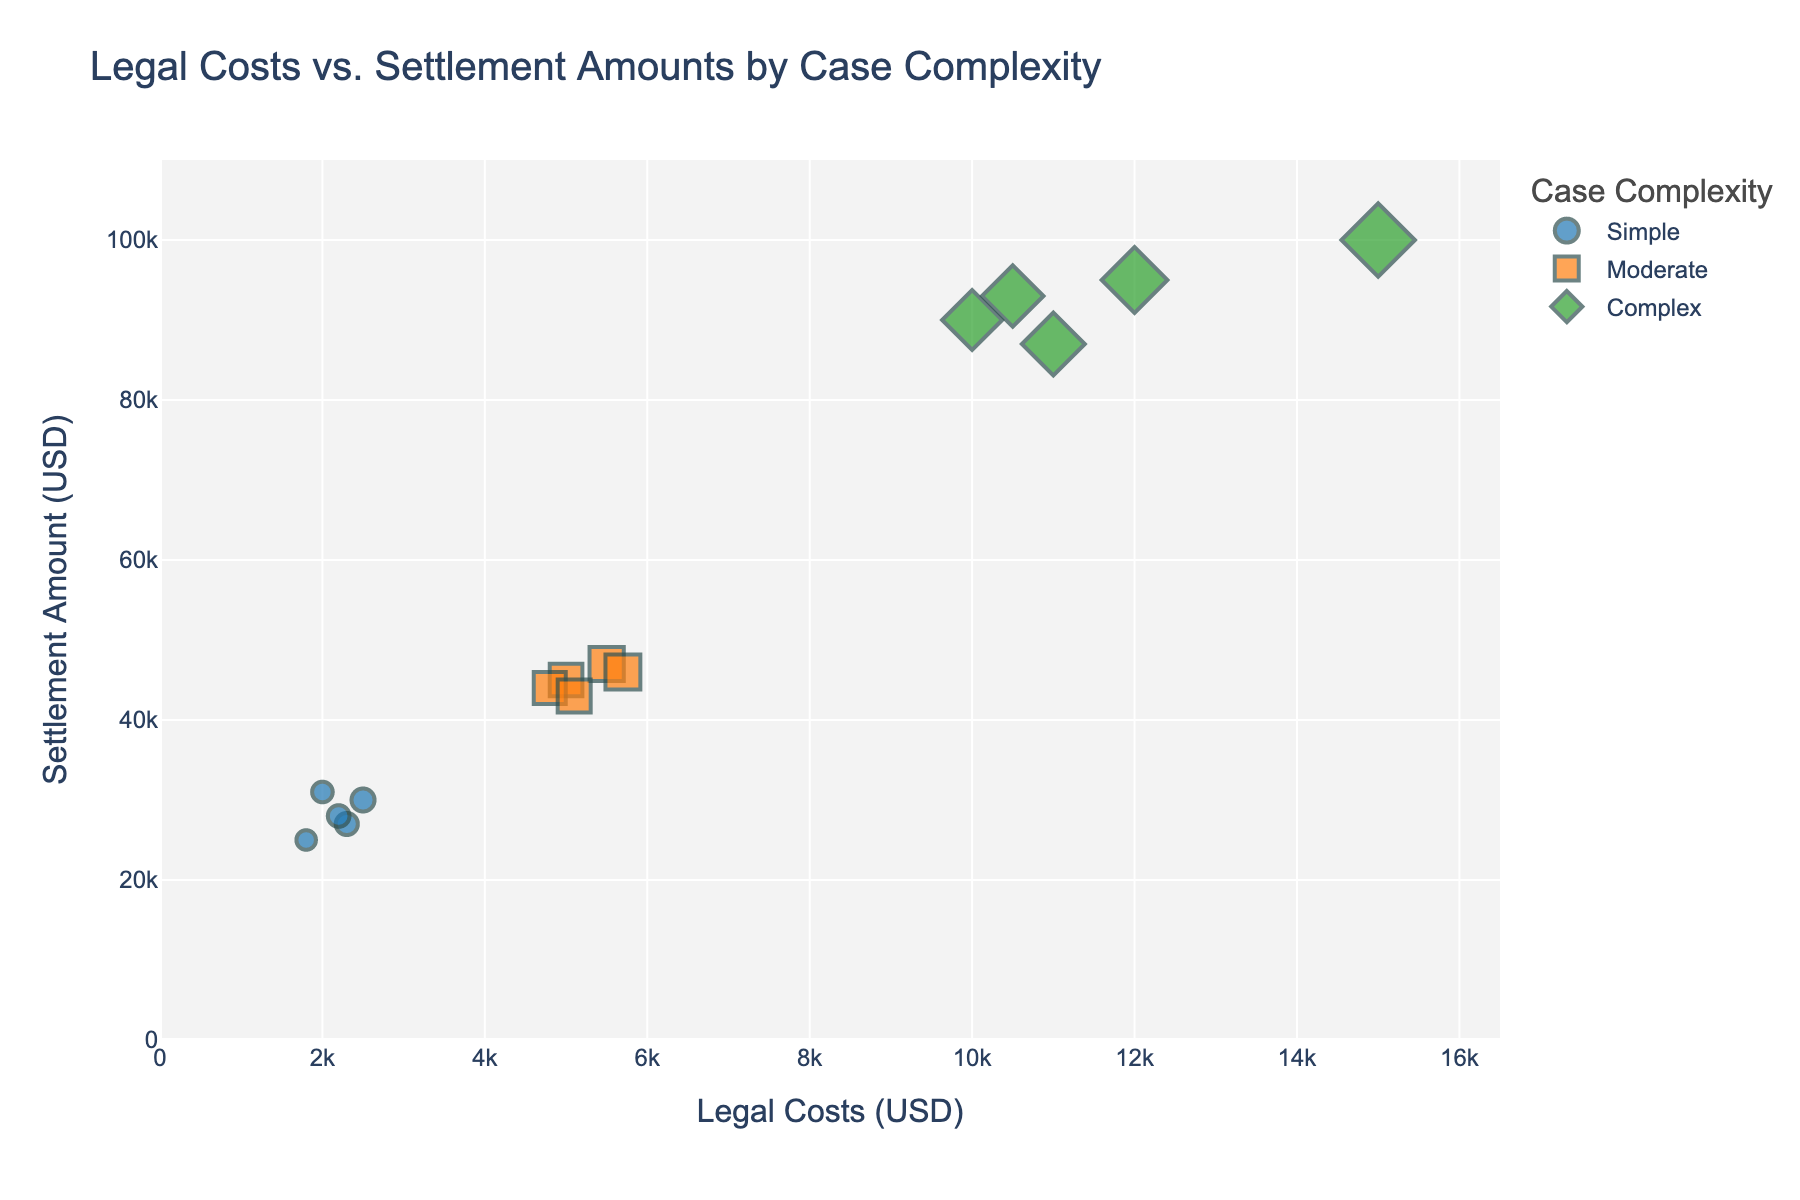How many data points are shown in the plot? By visually counting the markers of various shapes (circles, squares, diamonds) related to case complexity in the plot, you can identify there are 15 points
Answer: 15 Which case complexity has the highest legal costs? Observe that the largest markers represent 'Complex' cases. The maximum value observed among these markers shows that 'Complex' cases have the highest legal costs.
Answer: Complex What is the general trend between legal costs and settlement amounts? The scatter plot overall indicates a positive correlation, as higher legal costs generally align with higher settlement amounts. This can be seen by the upward diagonal pattern in the plotted data points.
Answer: Positive correlation What is the range of settlement amounts for 'Moderate' complexity cases? By identifying the 'Moderate' (square) markers, you can find the lowest and highest settlement amounts, which range from around 43,000 USD to 47,000 USD.
Answer: 43,000 to 47,000 USD Are there any 'Simple' cases with settlement amounts over 30,000 USD? Look for circle markers (representing 'Simple' cases) in the plot, and check their vertical position (settlement amount). There's one point visibly above 30,000 USD.
Answer: Yes What is the average legal cost for 'Complex' cases? Summing the legal costs for 'Complex' cases (diamonds) gives 58,500 USD (10,000 + 12,000 + 15,000 + 11,000 + 10,500). Dividing by the number of 'Complex' cases (5) gives an average. 58,500 / 5 = 11,700.
Answer: 11,700 USD Which case complexity has the smallest range in settlement amounts? By examining the settlement amount ranges for each complexity group (from lowest to highest points for circles, squares, diamonds), 'Simple' cases have the narrowest range from around 25,000 to 31,000 USD.
Answer: Simple What case ID has the highest settlement amount? Identify the point with the highest vertical position (settlement amount) and check the hover data embedded with the Case ID. The highest settlement amount corresponds to Case ID 9 (100,000 USD).
Answer: 9 